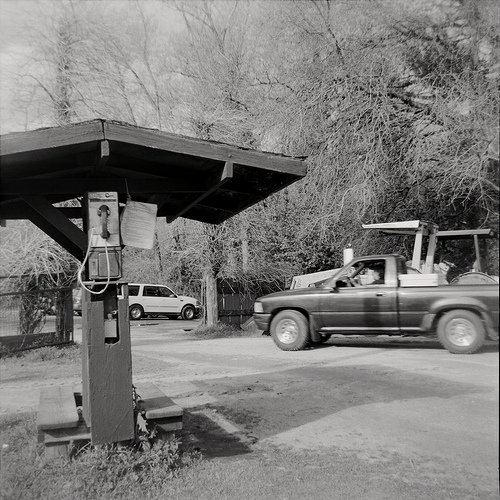Please provide the bounding box coordinate of the region this sentence describes: a phone on a wooden pole. The bounding box for the phone on a wooden pole is at coordinates [0.15, 0.29, 0.35, 0.72]. This captures the entire phone set up on the wooden structure. 